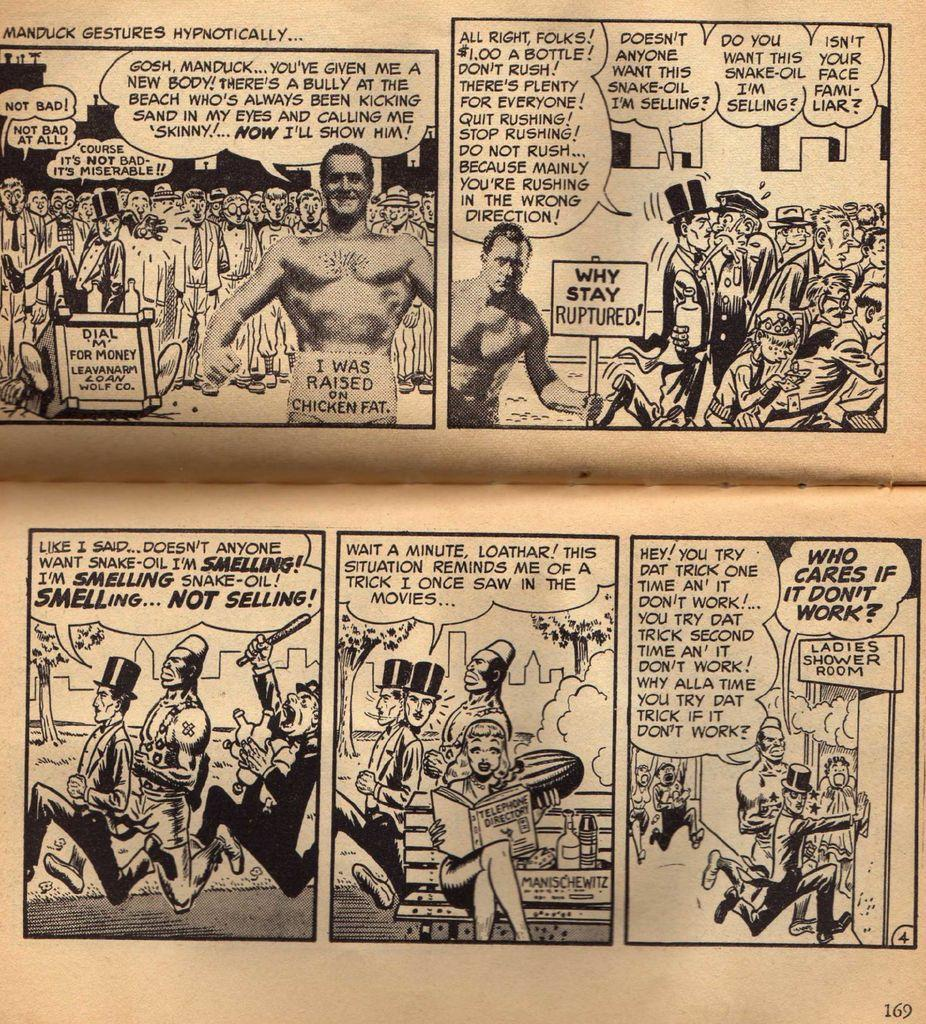Provide a one-sentence caption for the provided image. An insert from a newspaper of a comic strip depicting Manduck Gestures Hypothetically. 